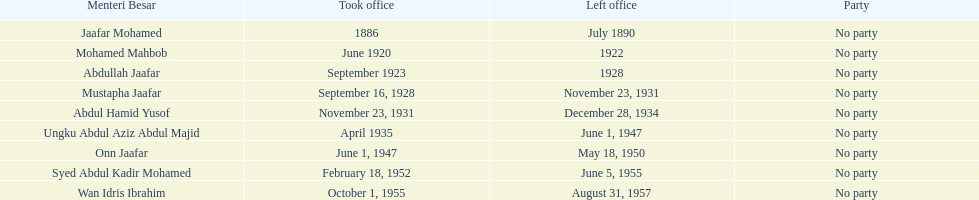Who is cited underneath onn jaafar? Syed Abdul Kadir Mohamed. 